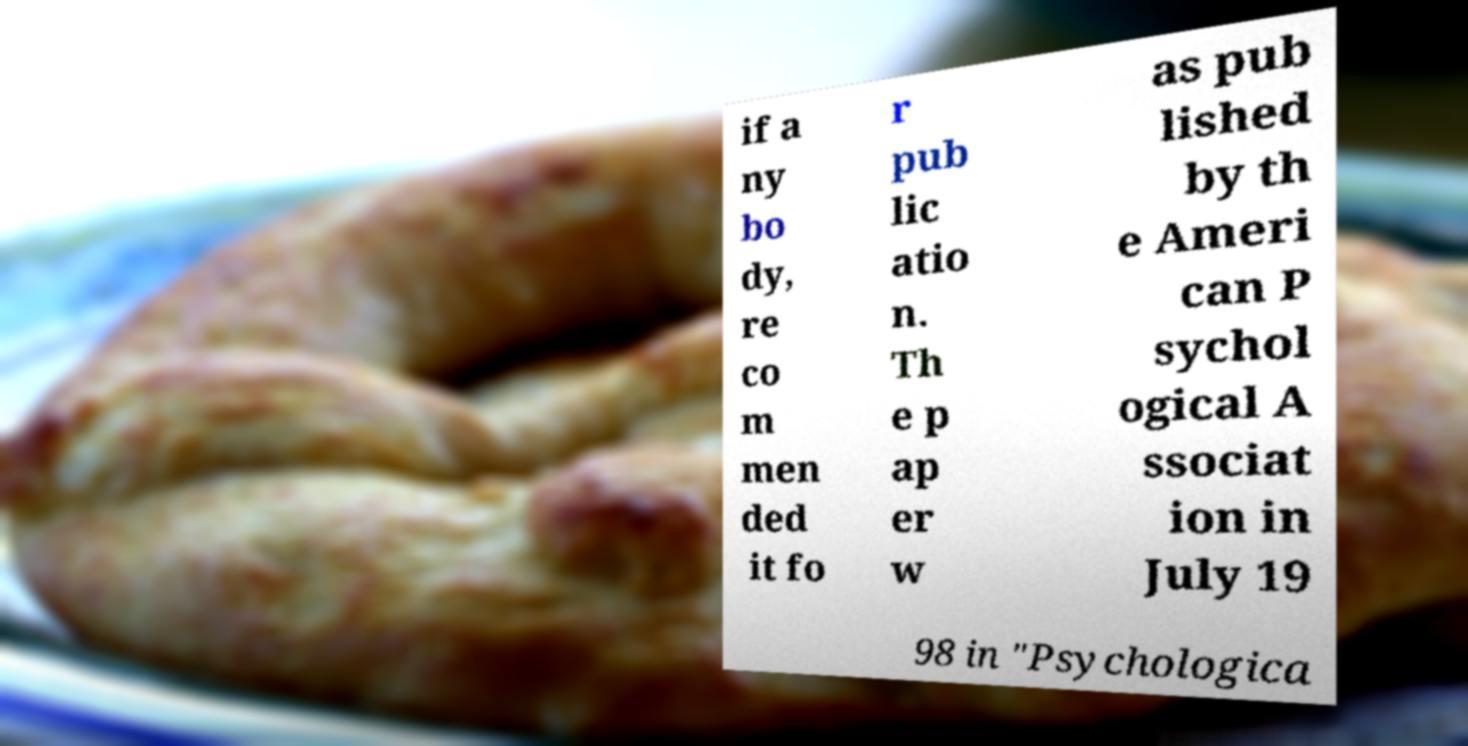Please identify and transcribe the text found in this image. if a ny bo dy, re co m men ded it fo r pub lic atio n. Th e p ap er w as pub lished by th e Ameri can P sychol ogical A ssociat ion in July 19 98 in "Psychologica 